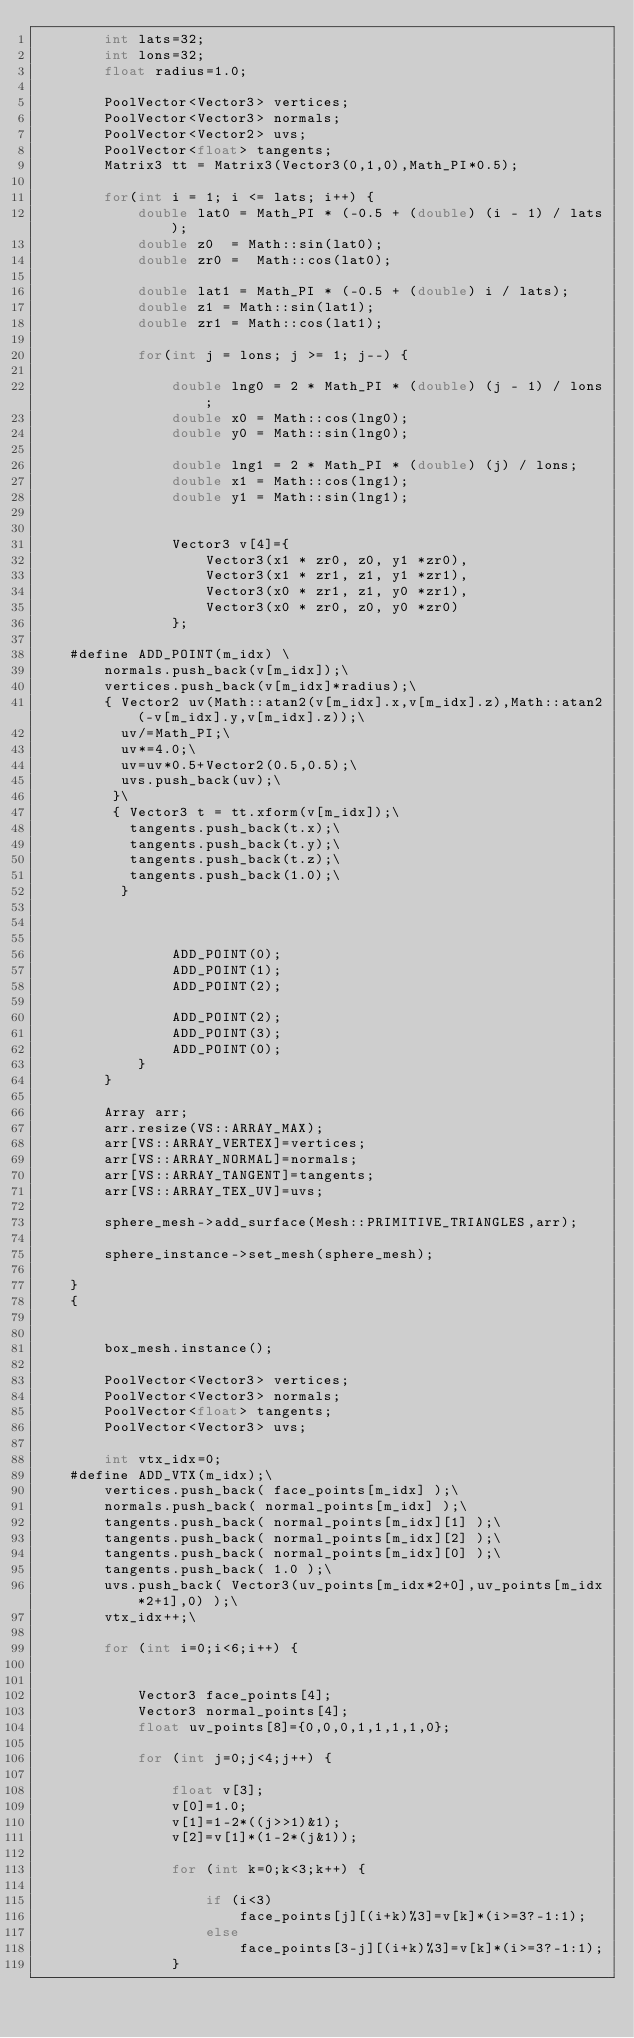<code> <loc_0><loc_0><loc_500><loc_500><_C++_>		int lats=32;
		int lons=32;
		float radius=1.0;

		PoolVector<Vector3> vertices;
		PoolVector<Vector3> normals;
		PoolVector<Vector2> uvs;
		PoolVector<float> tangents;
		Matrix3 tt = Matrix3(Vector3(0,1,0),Math_PI*0.5);

		for(int i = 1; i <= lats; i++) {
			double lat0 = Math_PI * (-0.5 + (double) (i - 1) / lats);
			double z0  = Math::sin(lat0);
			double zr0 =  Math::cos(lat0);

			double lat1 = Math_PI * (-0.5 + (double) i / lats);
			double z1 = Math::sin(lat1);
			double zr1 = Math::cos(lat1);

			for(int j = lons; j >= 1; j--) {

				double lng0 = 2 * Math_PI * (double) (j - 1) / lons;
				double x0 = Math::cos(lng0);
				double y0 = Math::sin(lng0);

				double lng1 = 2 * Math_PI * (double) (j) / lons;
				double x1 = Math::cos(lng1);
				double y1 = Math::sin(lng1);


				Vector3 v[4]={
					Vector3(x1 * zr0, z0, y1 *zr0),
					Vector3(x1 * zr1, z1, y1 *zr1),
					Vector3(x0 * zr1, z1, y0 *zr1),
					Vector3(x0 * zr0, z0, y0 *zr0)
				};

	#define ADD_POINT(m_idx) \
		normals.push_back(v[m_idx]);\
		vertices.push_back(v[m_idx]*radius);\
		{ Vector2 uv(Math::atan2(v[m_idx].x,v[m_idx].z),Math::atan2(-v[m_idx].y,v[m_idx].z));\
		  uv/=Math_PI;\
		  uv*=4.0;\
		  uv=uv*0.5+Vector2(0.5,0.5);\
		  uvs.push_back(uv);\
		 }\
		 { Vector3 t = tt.xform(v[m_idx]);\
		   tangents.push_back(t.x);\
		   tangents.push_back(t.y);\
		   tangents.push_back(t.z);\
		   tangents.push_back(1.0);\
		  }



				ADD_POINT(0);
				ADD_POINT(1);
				ADD_POINT(2);

				ADD_POINT(2);
				ADD_POINT(3);
				ADD_POINT(0);
			}
		}

		Array arr;
		arr.resize(VS::ARRAY_MAX);
		arr[VS::ARRAY_VERTEX]=vertices;
		arr[VS::ARRAY_NORMAL]=normals;
		arr[VS::ARRAY_TANGENT]=tangents;
		arr[VS::ARRAY_TEX_UV]=uvs;

		sphere_mesh->add_surface(Mesh::PRIMITIVE_TRIANGLES,arr);

		sphere_instance->set_mesh(sphere_mesh);

	}
	{


		box_mesh.instance();

		PoolVector<Vector3> vertices;
		PoolVector<Vector3> normals;
		PoolVector<float> tangents;
		PoolVector<Vector3> uvs;

		int vtx_idx=0;
	#define ADD_VTX(m_idx);\
		vertices.push_back( face_points[m_idx] );\
		normals.push_back( normal_points[m_idx] );\
		tangents.push_back( normal_points[m_idx][1] );\
		tangents.push_back( normal_points[m_idx][2] );\
		tangents.push_back( normal_points[m_idx][0] );\
		tangents.push_back( 1.0 );\
		uvs.push_back( Vector3(uv_points[m_idx*2+0],uv_points[m_idx*2+1],0) );\
		vtx_idx++;\

		for (int i=0;i<6;i++) {


			Vector3 face_points[4];
			Vector3 normal_points[4];
			float uv_points[8]={0,0,0,1,1,1,1,0};

			for (int j=0;j<4;j++) {

				float v[3];
				v[0]=1.0;
				v[1]=1-2*((j>>1)&1);
				v[2]=v[1]*(1-2*(j&1));

				for (int k=0;k<3;k++) {

					if (i<3)
						face_points[j][(i+k)%3]=v[k]*(i>=3?-1:1);
					else
						face_points[3-j][(i+k)%3]=v[k]*(i>=3?-1:1);
				}</code> 